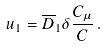Convert formula to latex. <formula><loc_0><loc_0><loc_500><loc_500>u _ { 1 } = \overline { D } _ { 1 } \delta \frac { C _ { \mu } } { C } \, .</formula> 